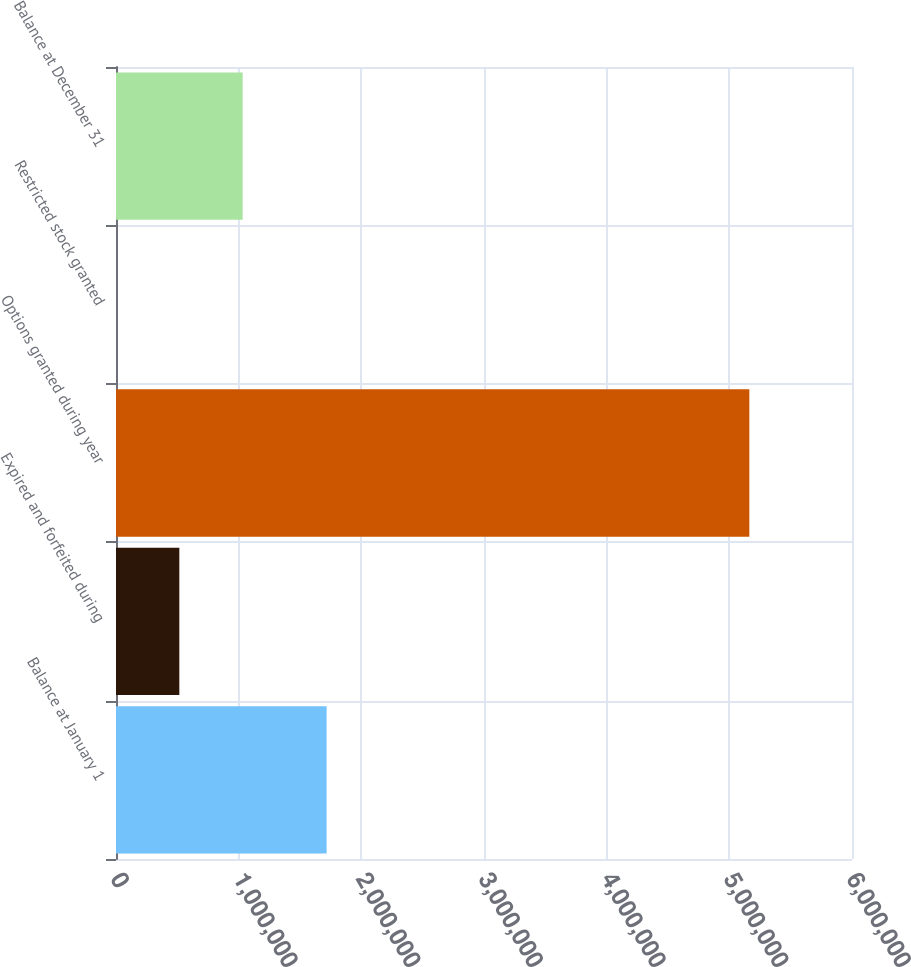Convert chart to OTSL. <chart><loc_0><loc_0><loc_500><loc_500><bar_chart><fcel>Balance at January 1<fcel>Expired and forfeited during<fcel>Options granted during year<fcel>Restricted stock granted<fcel>Balance at December 31<nl><fcel>1.71692e+06<fcel>516314<fcel>5.16312e+06<fcel>2.04<fcel>1.03263e+06<nl></chart> 